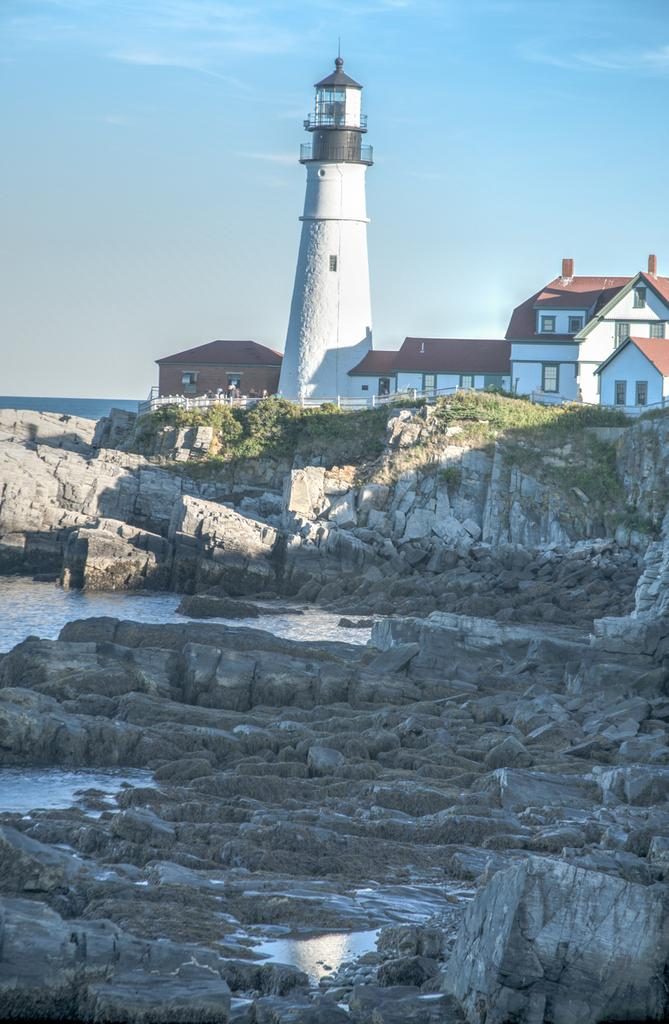What type of natural elements can be seen in the image? There are rocks, water, grass, and plants visible in the image. What type of man-made structures are present in the image? There is a railing, houses, and a lighthouse in the image. What is visible in the background of the image? The sky is visible in the background of the image. What type of bubble can be seen floating near the lighthouse in the image? There is no bubble present in the image; it features rocks, water, grass, plants, a railing, houses, and a lighthouse. Can you tell me how many cars are parked near the houses in the image? There is no car present in the image; it only features rocks, water, grass, plants, a railing, houses, and a lighthouse. 